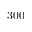Convert formula to latex. <formula><loc_0><loc_0><loc_500><loc_500>3 0 0</formula> 